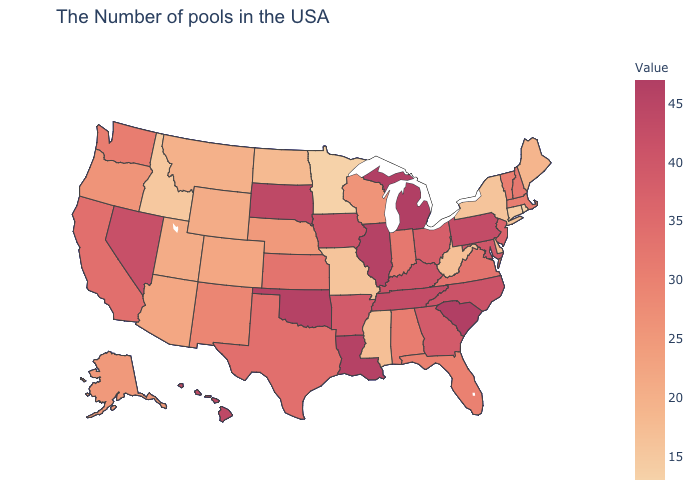Does the map have missing data?
Give a very brief answer. No. Among the states that border Indiana , which have the highest value?
Quick response, please. Michigan. Does Connecticut have the lowest value in the USA?
Be succinct. No. Does the map have missing data?
Be succinct. No. Which states have the highest value in the USA?
Write a very short answer. South Carolina, Michigan. Which states have the highest value in the USA?
Quick response, please. South Carolina, Michigan. 